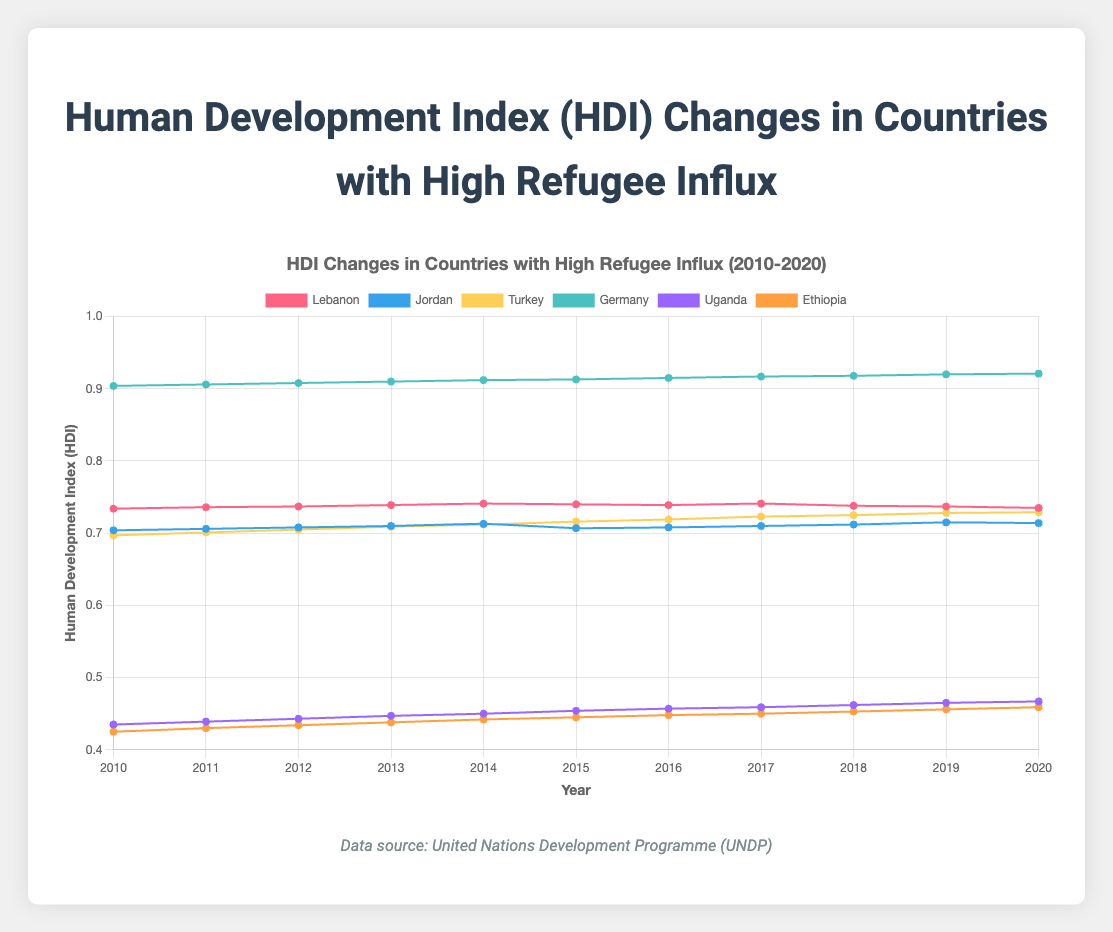What is the overall trend for the HDI in Lebanon from 2010 to 2020? To determine the overall trend, look at the data points for Lebanon from 2010 to 2020. Initially, the HDI increases, reaching a peak in 2014, then it declines slightly and fluctuates in the later years.
Answer: The overall trend shows a peak in 2014 followed by a slight decline Which country experienced the highest HDI in 2020, and what is its value? To identify the country with the highest HDI in 2020, look for the highest data point in the 2020 column. Germany has the highest HDI value in 2020, which is 0.921.
Answer: Germany, 0.921 Compare the HDI of Jordan and Uganda in 2015. To compare the HDI values, look at the 2015 data points for Jordan and Uganda. Jordan has an HDI of 0.707, whereas Uganda has an HDI of 0.454.
Answer: Jordan has a higher HDI than Uganda in 2015 Which country had the lowest HDI in 2010, and what was the value? To determine the country with the lowest HDI in 2010, find the lowest data point in the 2010 column. Ethiopia had the lowest HDI in 2010, with a value of 0.425.
Answer: Ethiopia, 0.425 How did the HDI in Turkey change from 2015 to 2020? To analyze the change, look at the HDI values for Turkey from 2015 (0.716) to 2020 (0.729). The HDI gradually increased each year.
Answer: The HDI in Turkey increased from 0.716 to 0.729 between 2015 and 2020 What is the difference in HDI values between Germany and Ethiopia in 2012? To find the difference, subtract Ethiopia's HDI in 2012 (0.434) from Germany's HDI in 2012 (0.908). The difference is 0.474.
Answer: The difference is 0.474 Identify the countries with an HDI value above 0.7 in 2020. Examine the HDI values for 2020 and identify those greater than 0.7. The countries are Lebanon (0.735), Jordan (0.714), Turkey (0.729), and Germany (0.921).
Answer: Lebanon, Jordan, Turkey, Germany By how much did the HDI in Uganda change from 2010 to 2020? Calculate the difference between Uganda's HDI in 2020 (0.467) and 2010 (0.435). The change is 0.032.
Answer: The change is 0.032 What is the average HDI of Germany from 2010 to 2020? Find the average by summing all yearly HDI values for Germany and dividing by the number of years. The sum is (0.904 + 0.906 + 0.908 + 0.910 + 0.912 + 0.913 + 0.915 + 0.917 + 0.918 + 0.920 + 0.921) = 10.444. The average is 10.444/11 = 0.949.
Answer: The average is 0.949 How did the HDI of Ethiopia progress over the period from 2010 to 2020? Observe the HDI values of Ethiopia from 2010 (0.425) to 2020 (0.459). It shows a consistent upward trend each year.
Answer: The HDI of Ethiopia consistently increased 